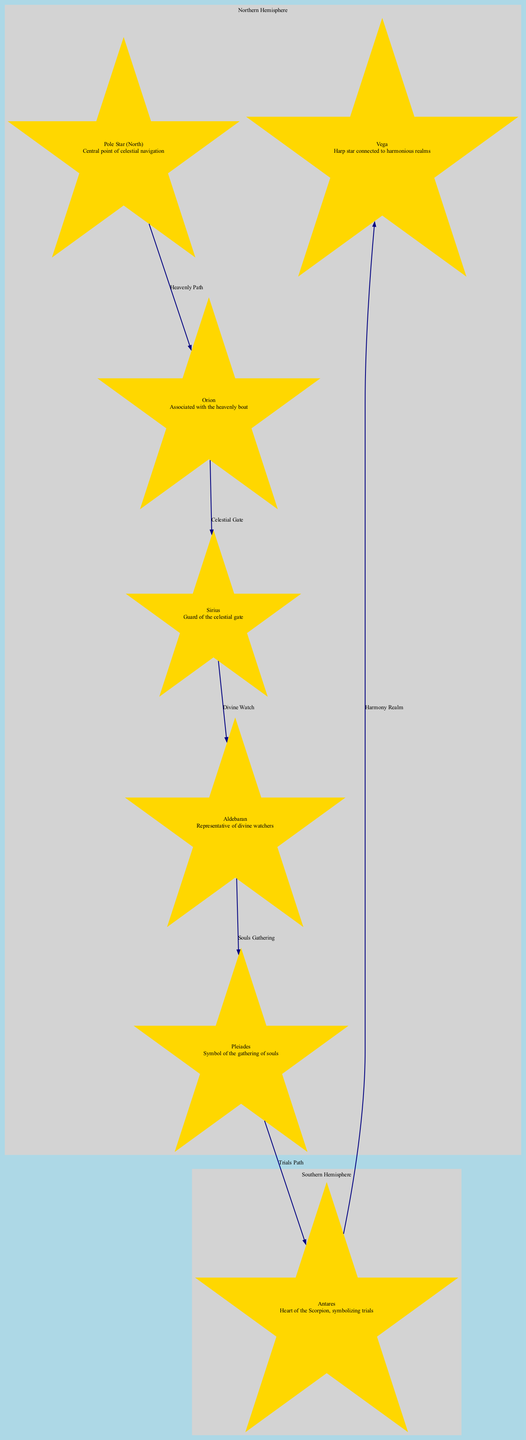What is the central point of celestial navigation? The diagram lists the "Pole Star" as the central point of celestial navigation, as indicated in its description.
Answer: Pole Star Which star is associated with the heavenly boat? According to the diagram, "Orion" is listed as the star associated with the heavenly boat, mentioned in its description.
Answer: Orion How many edges are in the diagram? By counting the relationships defined in the edges, there are a total of 6 edges connecting the stars.
Answer: 6 What is the significance of Sirius in the Mandaean tradition? The diagram describes "Sirius" as the guard of the celestial gate, providing insight into its significance.
Answer: Guard of the celestial gate Which star symbolizes the gathering of souls? The diagram identifies "Pleiades" as the star symbolizing the gathering of souls, as described.
Answer: Pleiades Which constellation is connected to "Antares" through the "Trials Path"? Following the edges in the diagram, "Pleiades" is the constellation connected to "Antares" through the "Trials Path."
Answer: Pleiades What is the significance of Vega? The diagram describes "Vega" as the harp star connected to harmonious realms, indicating its significance.
Answer: Harp star connected to harmonious realms In which zone is the "Pole Star" located? The diagram shows that "Pole Star" is included in the "Northern Hemisphere" zone as per the zone inclusions.
Answer: Northern Hemisphere Which two stars are part of the heavenly path? The diagram indicates that "Pole Star" and "Orion" are connected by the edge labeled "Heavenly Path."
Answer: Pole Star, Orion 